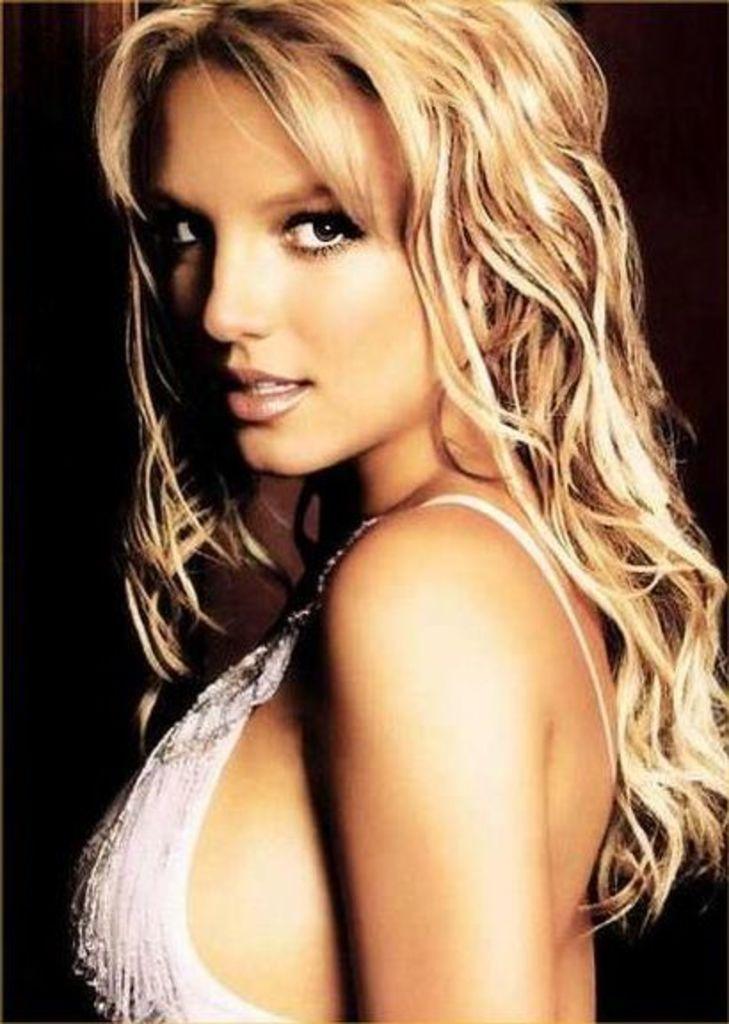Please provide a concise description of this image. In this image I see a woman and she is wearing white dress and it is dark in the background. 